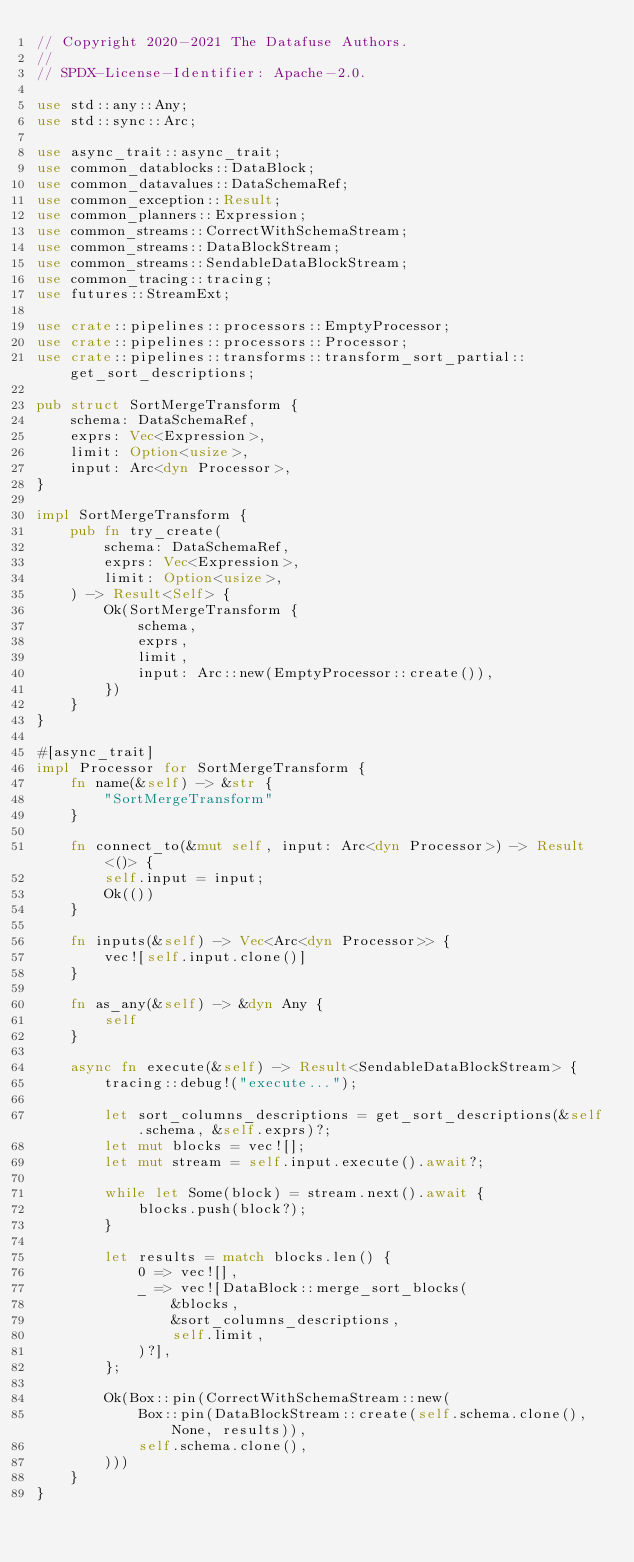Convert code to text. <code><loc_0><loc_0><loc_500><loc_500><_Rust_>// Copyright 2020-2021 The Datafuse Authors.
//
// SPDX-License-Identifier: Apache-2.0.

use std::any::Any;
use std::sync::Arc;

use async_trait::async_trait;
use common_datablocks::DataBlock;
use common_datavalues::DataSchemaRef;
use common_exception::Result;
use common_planners::Expression;
use common_streams::CorrectWithSchemaStream;
use common_streams::DataBlockStream;
use common_streams::SendableDataBlockStream;
use common_tracing::tracing;
use futures::StreamExt;

use crate::pipelines::processors::EmptyProcessor;
use crate::pipelines::processors::Processor;
use crate::pipelines::transforms::transform_sort_partial::get_sort_descriptions;

pub struct SortMergeTransform {
    schema: DataSchemaRef,
    exprs: Vec<Expression>,
    limit: Option<usize>,
    input: Arc<dyn Processor>,
}

impl SortMergeTransform {
    pub fn try_create(
        schema: DataSchemaRef,
        exprs: Vec<Expression>,
        limit: Option<usize>,
    ) -> Result<Self> {
        Ok(SortMergeTransform {
            schema,
            exprs,
            limit,
            input: Arc::new(EmptyProcessor::create()),
        })
    }
}

#[async_trait]
impl Processor for SortMergeTransform {
    fn name(&self) -> &str {
        "SortMergeTransform"
    }

    fn connect_to(&mut self, input: Arc<dyn Processor>) -> Result<()> {
        self.input = input;
        Ok(())
    }

    fn inputs(&self) -> Vec<Arc<dyn Processor>> {
        vec![self.input.clone()]
    }

    fn as_any(&self) -> &dyn Any {
        self
    }

    async fn execute(&self) -> Result<SendableDataBlockStream> {
        tracing::debug!("execute...");

        let sort_columns_descriptions = get_sort_descriptions(&self.schema, &self.exprs)?;
        let mut blocks = vec![];
        let mut stream = self.input.execute().await?;

        while let Some(block) = stream.next().await {
            blocks.push(block?);
        }

        let results = match blocks.len() {
            0 => vec![],
            _ => vec![DataBlock::merge_sort_blocks(
                &blocks,
                &sort_columns_descriptions,
                self.limit,
            )?],
        };

        Ok(Box::pin(CorrectWithSchemaStream::new(
            Box::pin(DataBlockStream::create(self.schema.clone(), None, results)),
            self.schema.clone(),
        )))
    }
}
</code> 